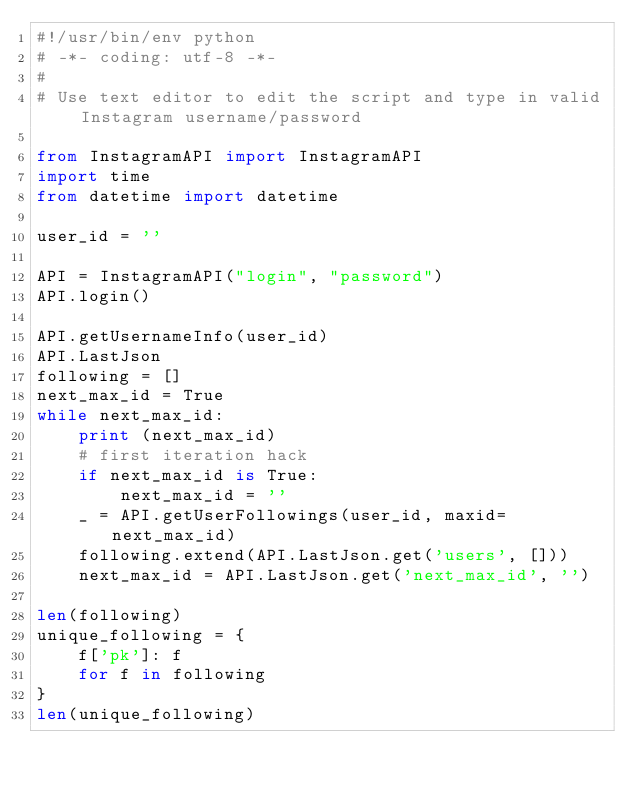Convert code to text. <code><loc_0><loc_0><loc_500><loc_500><_Python_>#!/usr/bin/env python
# -*- coding: utf-8 -*-
#
# Use text editor to edit the script and type in valid Instagram username/password

from InstagramAPI import InstagramAPI
import time
from datetime import datetime

user_id = ''

API = InstagramAPI("login", "password")
API.login()

API.getUsernameInfo(user_id)
API.LastJson
following = []
next_max_id = True
while next_max_id:
    print (next_max_id)
    # first iteration hack
    if next_max_id is True:
        next_max_id = ''
    _ = API.getUserFollowings(user_id, maxid=next_max_id)
    following.extend(API.LastJson.get('users', []))
    next_max_id = API.LastJson.get('next_max_id', '')

len(following)
unique_following = {
    f['pk']: f
    for f in following
}
len(unique_following)
</code> 